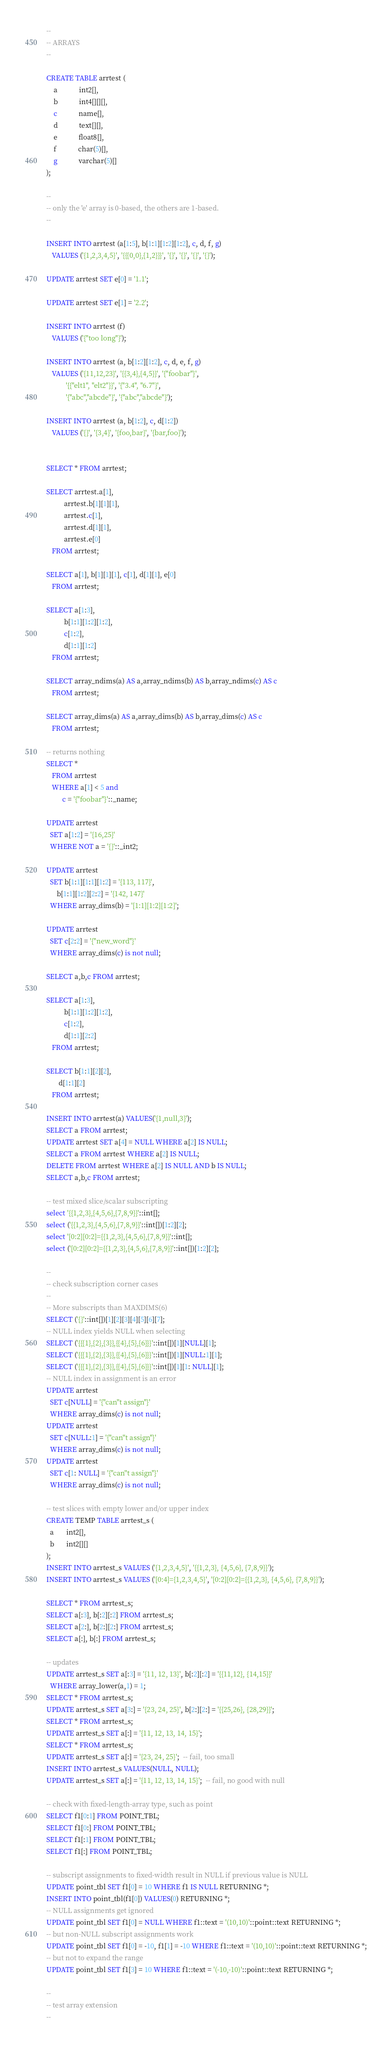<code> <loc_0><loc_0><loc_500><loc_500><_SQL_>--
-- ARRAYS
--

CREATE TABLE arrtest (
	a 			int2[],
	b 			int4[][][],
	c 			name[],
	d 			text[][],
	e 			float8[],
	f 			char(5)[],
	g 			varchar(5)[]
);

--
-- only the 'e' array is 0-based, the others are 1-based.
--

INSERT INTO arrtest (a[1:5], b[1:1][1:2][1:2], c, d, f, g)
   VALUES ('{1,2,3,4,5}', '{{{0,0},{1,2}}}', '{}', '{}', '{}', '{}');

UPDATE arrtest SET e[0] = '1.1';

UPDATE arrtest SET e[1] = '2.2';

INSERT INTO arrtest (f)
   VALUES ('{"too long"}');

INSERT INTO arrtest (a, b[1:2][1:2], c, d, e, f, g)
   VALUES ('{11,12,23}', '{{3,4},{4,5}}', '{"foobar"}',
           '{{"elt1", "elt2"}}', '{"3.4", "6.7"}',
           '{"abc","abcde"}', '{"abc","abcde"}');

INSERT INTO arrtest (a, b[1:2], c, d[1:2])
   VALUES ('{}', '{3,4}', '{foo,bar}', '{bar,foo}');


SELECT * FROM arrtest;

SELECT arrtest.a[1],
          arrtest.b[1][1][1],
          arrtest.c[1],
          arrtest.d[1][1],
          arrtest.e[0]
   FROM arrtest;

SELECT a[1], b[1][1][1], c[1], d[1][1], e[0]
   FROM arrtest;

SELECT a[1:3],
          b[1:1][1:2][1:2],
          c[1:2],
          d[1:1][1:2]
   FROM arrtest;

SELECT array_ndims(a) AS a,array_ndims(b) AS b,array_ndims(c) AS c
   FROM arrtest;

SELECT array_dims(a) AS a,array_dims(b) AS b,array_dims(c) AS c
   FROM arrtest;

-- returns nothing
SELECT *
   FROM arrtest
   WHERE a[1] < 5 and
         c = '{"foobar"}'::_name;

UPDATE arrtest
  SET a[1:2] = '{16,25}'
  WHERE NOT a = '{}'::_int2;

UPDATE arrtest
  SET b[1:1][1:1][1:2] = '{113, 117}',
      b[1:1][1:2][2:2] = '{142, 147}'
  WHERE array_dims(b) = '[1:1][1:2][1:2]';

UPDATE arrtest
  SET c[2:2] = '{"new_word"}'
  WHERE array_dims(c) is not null;

SELECT a,b,c FROM arrtest;

SELECT a[1:3],
          b[1:1][1:2][1:2],
          c[1:2],
          d[1:1][2:2]
   FROM arrtest;

SELECT b[1:1][2][2],
       d[1:1][2]
   FROM arrtest;

INSERT INTO arrtest(a) VALUES('{1,null,3}');
SELECT a FROM arrtest;
UPDATE arrtest SET a[4] = NULL WHERE a[2] IS NULL;
SELECT a FROM arrtest WHERE a[2] IS NULL;
DELETE FROM arrtest WHERE a[2] IS NULL AND b IS NULL;
SELECT a,b,c FROM arrtest;

-- test mixed slice/scalar subscripting
select '{{1,2,3},{4,5,6},{7,8,9}}'::int[];
select ('{{1,2,3},{4,5,6},{7,8,9}}'::int[])[1:2][2];
select '[0:2][0:2]={{1,2,3},{4,5,6},{7,8,9}}'::int[];
select ('[0:2][0:2]={{1,2,3},{4,5,6},{7,8,9}}'::int[])[1:2][2];

--
-- check subscription corner cases
--
-- More subscripts than MAXDIMS(6)
SELECT ('{}'::int[])[1][2][3][4][5][6][7];
-- NULL index yields NULL when selecting
SELECT ('{{{1},{2},{3}},{{4},{5},{6}}}'::int[])[1][NULL][1];
SELECT ('{{{1},{2},{3}},{{4},{5},{6}}}'::int[])[1][NULL:1][1];
SELECT ('{{{1},{2},{3}},{{4},{5},{6}}}'::int[])[1][1: NULL][1];
-- NULL index in assignment is an error
UPDATE arrtest
  SET c[NULL] = '{"can''t assign"}'
  WHERE array_dims(c) is not null;
UPDATE arrtest
  SET c[NULL:1] = '{"can''t assign"}'
  WHERE array_dims(c) is not null;
UPDATE arrtest
  SET c[1: NULL] = '{"can''t assign"}'
  WHERE array_dims(c) is not null;

-- test slices with empty lower and/or upper index
CREATE TEMP TABLE arrtest_s (
  a       int2[],
  b       int2[][]
);
INSERT INTO arrtest_s VALUES ('{1,2,3,4,5}', '{{1,2,3}, {4,5,6}, {7,8,9}}');
INSERT INTO arrtest_s VALUES ('[0:4]={1,2,3,4,5}', '[0:2][0:2]={{1,2,3}, {4,5,6}, {7,8,9}}');

SELECT * FROM arrtest_s;
SELECT a[:3], b[:2][:2] FROM arrtest_s;
SELECT a[2:], b[2:][2:] FROM arrtest_s;
SELECT a[:], b[:] FROM arrtest_s;

-- updates
UPDATE arrtest_s SET a[:3] = '{11, 12, 13}', b[:2][:2] = '{{11,12}, {14,15}}'
  WHERE array_lower(a,1) = 1;
SELECT * FROM arrtest_s;
UPDATE arrtest_s SET a[3:] = '{23, 24, 25}', b[2:][2:] = '{{25,26}, {28,29}}';
SELECT * FROM arrtest_s;
UPDATE arrtest_s SET a[:] = '{11, 12, 13, 14, 15}';
SELECT * FROM arrtest_s;
UPDATE arrtest_s SET a[:] = '{23, 24, 25}';  -- fail, too small
INSERT INTO arrtest_s VALUES(NULL, NULL);
UPDATE arrtest_s SET a[:] = '{11, 12, 13, 14, 15}';  -- fail, no good with null

-- check with fixed-length-array type, such as point
SELECT f1[0:1] FROM POINT_TBL;
SELECT f1[0:] FROM POINT_TBL;
SELECT f1[:1] FROM POINT_TBL;
SELECT f1[:] FROM POINT_TBL;

-- subscript assignments to fixed-width result in NULL if previous value is NULL
UPDATE point_tbl SET f1[0] = 10 WHERE f1 IS NULL RETURNING *;
INSERT INTO point_tbl(f1[0]) VALUES(0) RETURNING *;
-- NULL assignments get ignored
UPDATE point_tbl SET f1[0] = NULL WHERE f1::text = '(10,10)'::point::text RETURNING *;
-- but non-NULL subscript assignments work
UPDATE point_tbl SET f1[0] = -10, f1[1] = -10 WHERE f1::text = '(10,10)'::point::text RETURNING *;
-- but not to expand the range
UPDATE point_tbl SET f1[3] = 10 WHERE f1::text = '(-10,-10)'::point::text RETURNING *;

--
-- test array extension
--</code> 